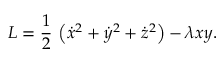<formula> <loc_0><loc_0><loc_500><loc_500>L = \frac { 1 } { 2 } \, \left ( \dot { x } ^ { 2 } + \dot { y } ^ { 2 } + \dot { z } ^ { 2 } \right ) - \lambda x y .</formula> 